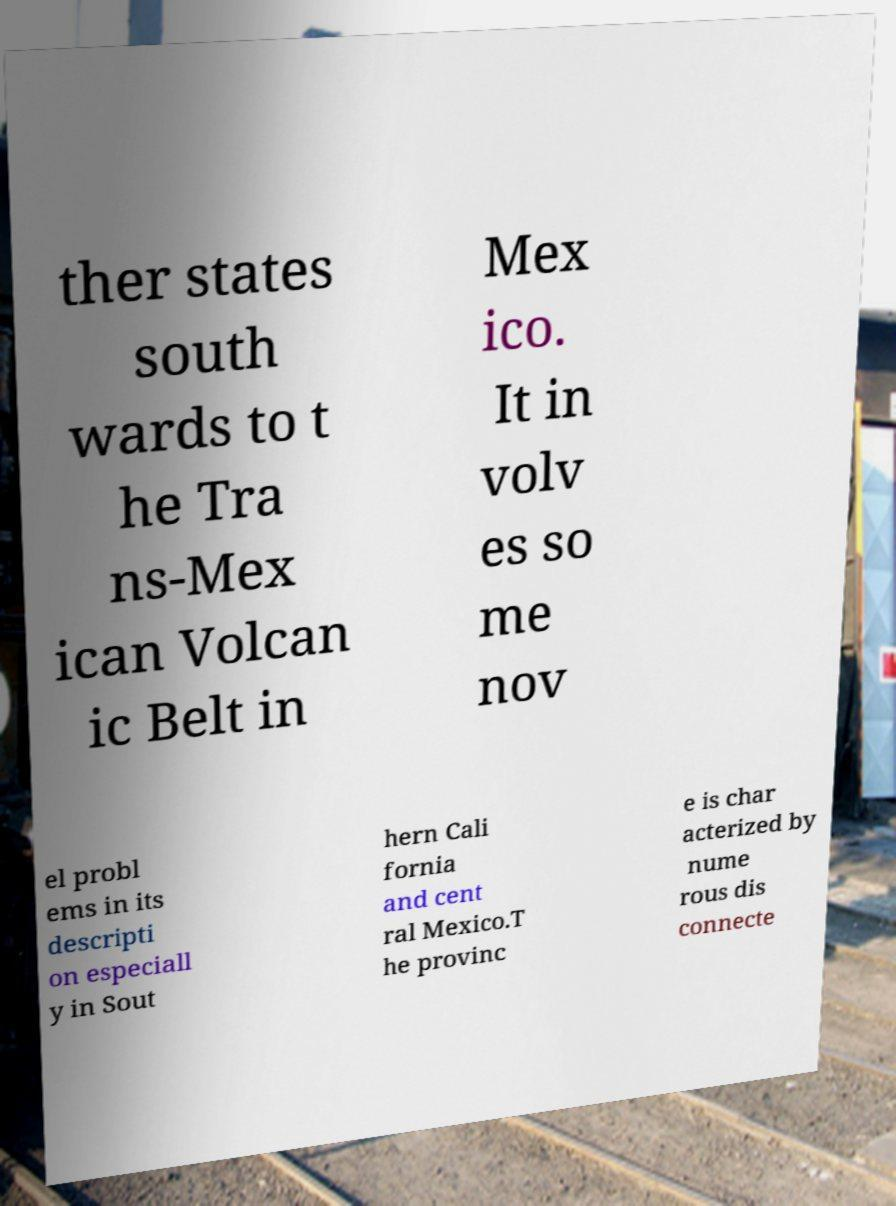I need the written content from this picture converted into text. Can you do that? ther states south wards to t he Tra ns-Mex ican Volcan ic Belt in Mex ico. It in volv es so me nov el probl ems in its descripti on especiall y in Sout hern Cali fornia and cent ral Mexico.T he provinc e is char acterized by nume rous dis connecte 